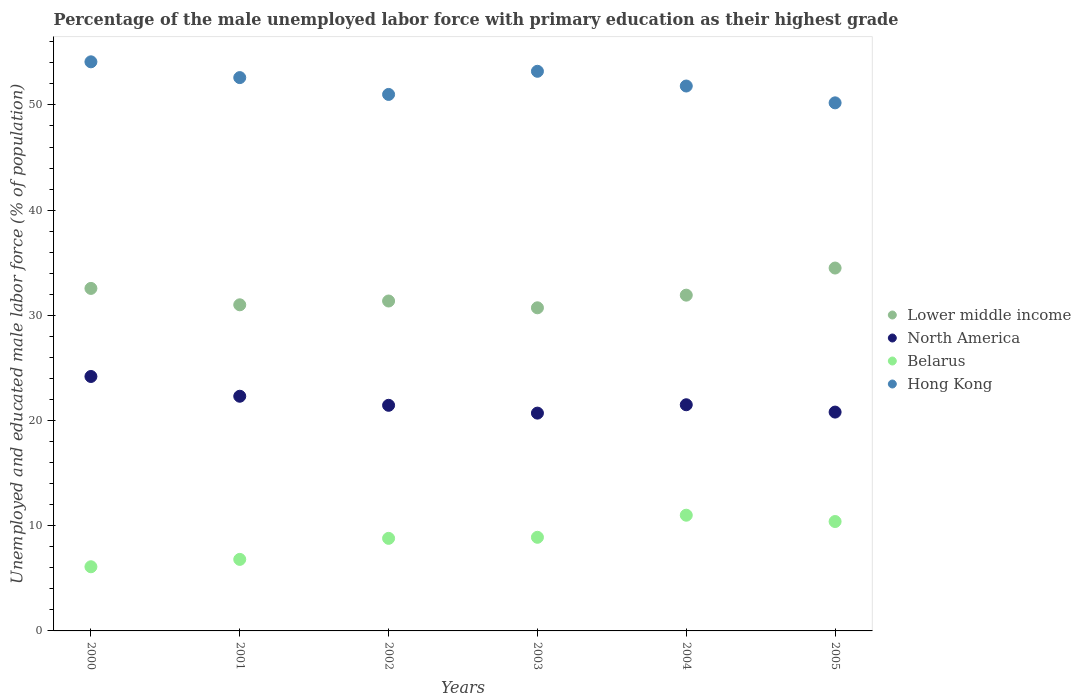How many different coloured dotlines are there?
Provide a succinct answer. 4. Is the number of dotlines equal to the number of legend labels?
Your answer should be compact. Yes. What is the percentage of the unemployed male labor force with primary education in Belarus in 2000?
Keep it short and to the point. 6.1. Across all years, what is the maximum percentage of the unemployed male labor force with primary education in Hong Kong?
Give a very brief answer. 54.1. Across all years, what is the minimum percentage of the unemployed male labor force with primary education in Hong Kong?
Ensure brevity in your answer.  50.2. What is the total percentage of the unemployed male labor force with primary education in North America in the graph?
Provide a succinct answer. 130.95. What is the difference between the percentage of the unemployed male labor force with primary education in Hong Kong in 2000 and that in 2004?
Make the answer very short. 2.3. What is the difference between the percentage of the unemployed male labor force with primary education in Hong Kong in 2004 and the percentage of the unemployed male labor force with primary education in Lower middle income in 2005?
Your answer should be compact. 17.3. What is the average percentage of the unemployed male labor force with primary education in Lower middle income per year?
Give a very brief answer. 32.01. In the year 2003, what is the difference between the percentage of the unemployed male labor force with primary education in Belarus and percentage of the unemployed male labor force with primary education in Hong Kong?
Make the answer very short. -44.3. In how many years, is the percentage of the unemployed male labor force with primary education in Lower middle income greater than 54 %?
Ensure brevity in your answer.  0. What is the ratio of the percentage of the unemployed male labor force with primary education in Lower middle income in 2003 to that in 2004?
Give a very brief answer. 0.96. Is the difference between the percentage of the unemployed male labor force with primary education in Belarus in 2002 and 2005 greater than the difference between the percentage of the unemployed male labor force with primary education in Hong Kong in 2002 and 2005?
Your answer should be compact. No. What is the difference between the highest and the second highest percentage of the unemployed male labor force with primary education in Lower middle income?
Make the answer very short. 1.94. What is the difference between the highest and the lowest percentage of the unemployed male labor force with primary education in North America?
Keep it short and to the point. 3.48. In how many years, is the percentage of the unemployed male labor force with primary education in North America greater than the average percentage of the unemployed male labor force with primary education in North America taken over all years?
Give a very brief answer. 2. Is the sum of the percentage of the unemployed male labor force with primary education in Hong Kong in 2000 and 2002 greater than the maximum percentage of the unemployed male labor force with primary education in Belarus across all years?
Ensure brevity in your answer.  Yes. Is it the case that in every year, the sum of the percentage of the unemployed male labor force with primary education in Lower middle income and percentage of the unemployed male labor force with primary education in Belarus  is greater than the sum of percentage of the unemployed male labor force with primary education in Hong Kong and percentage of the unemployed male labor force with primary education in North America?
Offer a terse response. No. Is it the case that in every year, the sum of the percentage of the unemployed male labor force with primary education in Lower middle income and percentage of the unemployed male labor force with primary education in Belarus  is greater than the percentage of the unemployed male labor force with primary education in North America?
Your answer should be compact. Yes. How many dotlines are there?
Give a very brief answer. 4. Are the values on the major ticks of Y-axis written in scientific E-notation?
Give a very brief answer. No. Does the graph contain any zero values?
Make the answer very short. No. What is the title of the graph?
Your response must be concise. Percentage of the male unemployed labor force with primary education as their highest grade. What is the label or title of the Y-axis?
Give a very brief answer. Unemployed and educated male labor force (% of population). What is the Unemployed and educated male labor force (% of population) in Lower middle income in 2000?
Provide a short and direct response. 32.56. What is the Unemployed and educated male labor force (% of population) in North America in 2000?
Make the answer very short. 24.19. What is the Unemployed and educated male labor force (% of population) in Belarus in 2000?
Your answer should be very brief. 6.1. What is the Unemployed and educated male labor force (% of population) of Hong Kong in 2000?
Offer a terse response. 54.1. What is the Unemployed and educated male labor force (% of population) of Lower middle income in 2001?
Keep it short and to the point. 31. What is the Unemployed and educated male labor force (% of population) in North America in 2001?
Ensure brevity in your answer.  22.31. What is the Unemployed and educated male labor force (% of population) of Belarus in 2001?
Offer a very short reply. 6.8. What is the Unemployed and educated male labor force (% of population) in Hong Kong in 2001?
Ensure brevity in your answer.  52.6. What is the Unemployed and educated male labor force (% of population) of Lower middle income in 2002?
Give a very brief answer. 31.36. What is the Unemployed and educated male labor force (% of population) in North America in 2002?
Your answer should be compact. 21.45. What is the Unemployed and educated male labor force (% of population) of Belarus in 2002?
Your answer should be compact. 8.8. What is the Unemployed and educated male labor force (% of population) in Lower middle income in 2003?
Make the answer very short. 30.72. What is the Unemployed and educated male labor force (% of population) of North America in 2003?
Offer a terse response. 20.7. What is the Unemployed and educated male labor force (% of population) in Belarus in 2003?
Your response must be concise. 8.9. What is the Unemployed and educated male labor force (% of population) of Hong Kong in 2003?
Give a very brief answer. 53.2. What is the Unemployed and educated male labor force (% of population) of Lower middle income in 2004?
Provide a short and direct response. 31.92. What is the Unemployed and educated male labor force (% of population) in North America in 2004?
Offer a very short reply. 21.5. What is the Unemployed and educated male labor force (% of population) in Hong Kong in 2004?
Your answer should be compact. 51.8. What is the Unemployed and educated male labor force (% of population) of Lower middle income in 2005?
Offer a terse response. 34.5. What is the Unemployed and educated male labor force (% of population) in North America in 2005?
Give a very brief answer. 20.8. What is the Unemployed and educated male labor force (% of population) of Belarus in 2005?
Your response must be concise. 10.4. What is the Unemployed and educated male labor force (% of population) of Hong Kong in 2005?
Your response must be concise. 50.2. Across all years, what is the maximum Unemployed and educated male labor force (% of population) of Lower middle income?
Make the answer very short. 34.5. Across all years, what is the maximum Unemployed and educated male labor force (% of population) of North America?
Provide a succinct answer. 24.19. Across all years, what is the maximum Unemployed and educated male labor force (% of population) in Hong Kong?
Your answer should be compact. 54.1. Across all years, what is the minimum Unemployed and educated male labor force (% of population) of Lower middle income?
Your response must be concise. 30.72. Across all years, what is the minimum Unemployed and educated male labor force (% of population) in North America?
Offer a terse response. 20.7. Across all years, what is the minimum Unemployed and educated male labor force (% of population) in Belarus?
Give a very brief answer. 6.1. Across all years, what is the minimum Unemployed and educated male labor force (% of population) of Hong Kong?
Give a very brief answer. 50.2. What is the total Unemployed and educated male labor force (% of population) of Lower middle income in the graph?
Your response must be concise. 192.05. What is the total Unemployed and educated male labor force (% of population) of North America in the graph?
Your answer should be very brief. 130.95. What is the total Unemployed and educated male labor force (% of population) of Belarus in the graph?
Your response must be concise. 52. What is the total Unemployed and educated male labor force (% of population) of Hong Kong in the graph?
Your answer should be very brief. 312.9. What is the difference between the Unemployed and educated male labor force (% of population) of Lower middle income in 2000 and that in 2001?
Your answer should be very brief. 1.56. What is the difference between the Unemployed and educated male labor force (% of population) of North America in 2000 and that in 2001?
Provide a succinct answer. 1.88. What is the difference between the Unemployed and educated male labor force (% of population) in Lower middle income in 2000 and that in 2002?
Provide a short and direct response. 1.2. What is the difference between the Unemployed and educated male labor force (% of population) in North America in 2000 and that in 2002?
Give a very brief answer. 2.74. What is the difference between the Unemployed and educated male labor force (% of population) in Belarus in 2000 and that in 2002?
Provide a succinct answer. -2.7. What is the difference between the Unemployed and educated male labor force (% of population) in Lower middle income in 2000 and that in 2003?
Your response must be concise. 1.84. What is the difference between the Unemployed and educated male labor force (% of population) of North America in 2000 and that in 2003?
Ensure brevity in your answer.  3.48. What is the difference between the Unemployed and educated male labor force (% of population) of Lower middle income in 2000 and that in 2004?
Offer a terse response. 0.64. What is the difference between the Unemployed and educated male labor force (% of population) in North America in 2000 and that in 2004?
Offer a terse response. 2.69. What is the difference between the Unemployed and educated male labor force (% of population) in Lower middle income in 2000 and that in 2005?
Your response must be concise. -1.94. What is the difference between the Unemployed and educated male labor force (% of population) in North America in 2000 and that in 2005?
Ensure brevity in your answer.  3.38. What is the difference between the Unemployed and educated male labor force (% of population) of Belarus in 2000 and that in 2005?
Offer a terse response. -4.3. What is the difference between the Unemployed and educated male labor force (% of population) in Hong Kong in 2000 and that in 2005?
Give a very brief answer. 3.9. What is the difference between the Unemployed and educated male labor force (% of population) of Lower middle income in 2001 and that in 2002?
Your answer should be compact. -0.36. What is the difference between the Unemployed and educated male labor force (% of population) of North America in 2001 and that in 2002?
Offer a very short reply. 0.86. What is the difference between the Unemployed and educated male labor force (% of population) in Lower middle income in 2001 and that in 2003?
Your response must be concise. 0.28. What is the difference between the Unemployed and educated male labor force (% of population) in North America in 2001 and that in 2003?
Your answer should be very brief. 1.6. What is the difference between the Unemployed and educated male labor force (% of population) of Hong Kong in 2001 and that in 2003?
Offer a terse response. -0.6. What is the difference between the Unemployed and educated male labor force (% of population) of Lower middle income in 2001 and that in 2004?
Make the answer very short. -0.92. What is the difference between the Unemployed and educated male labor force (% of population) in North America in 2001 and that in 2004?
Ensure brevity in your answer.  0.81. What is the difference between the Unemployed and educated male labor force (% of population) in Belarus in 2001 and that in 2004?
Keep it short and to the point. -4.2. What is the difference between the Unemployed and educated male labor force (% of population) of Lower middle income in 2001 and that in 2005?
Your response must be concise. -3.49. What is the difference between the Unemployed and educated male labor force (% of population) of North America in 2001 and that in 2005?
Your answer should be very brief. 1.51. What is the difference between the Unemployed and educated male labor force (% of population) of Lower middle income in 2002 and that in 2003?
Offer a very short reply. 0.65. What is the difference between the Unemployed and educated male labor force (% of population) in North America in 2002 and that in 2003?
Offer a very short reply. 0.74. What is the difference between the Unemployed and educated male labor force (% of population) in Lower middle income in 2002 and that in 2004?
Make the answer very short. -0.56. What is the difference between the Unemployed and educated male labor force (% of population) in North America in 2002 and that in 2004?
Offer a terse response. -0.05. What is the difference between the Unemployed and educated male labor force (% of population) of Belarus in 2002 and that in 2004?
Keep it short and to the point. -2.2. What is the difference between the Unemployed and educated male labor force (% of population) of Lower middle income in 2002 and that in 2005?
Offer a very short reply. -3.13. What is the difference between the Unemployed and educated male labor force (% of population) of North America in 2002 and that in 2005?
Offer a terse response. 0.65. What is the difference between the Unemployed and educated male labor force (% of population) in Belarus in 2002 and that in 2005?
Provide a short and direct response. -1.6. What is the difference between the Unemployed and educated male labor force (% of population) in Lower middle income in 2003 and that in 2004?
Your answer should be compact. -1.2. What is the difference between the Unemployed and educated male labor force (% of population) of North America in 2003 and that in 2004?
Ensure brevity in your answer.  -0.8. What is the difference between the Unemployed and educated male labor force (% of population) of Hong Kong in 2003 and that in 2004?
Keep it short and to the point. 1.4. What is the difference between the Unemployed and educated male labor force (% of population) in Lower middle income in 2003 and that in 2005?
Make the answer very short. -3.78. What is the difference between the Unemployed and educated male labor force (% of population) of North America in 2003 and that in 2005?
Keep it short and to the point. -0.1. What is the difference between the Unemployed and educated male labor force (% of population) of Belarus in 2003 and that in 2005?
Offer a very short reply. -1.5. What is the difference between the Unemployed and educated male labor force (% of population) in Lower middle income in 2004 and that in 2005?
Keep it short and to the point. -2.58. What is the difference between the Unemployed and educated male labor force (% of population) in North America in 2004 and that in 2005?
Keep it short and to the point. 0.7. What is the difference between the Unemployed and educated male labor force (% of population) of Belarus in 2004 and that in 2005?
Offer a terse response. 0.6. What is the difference between the Unemployed and educated male labor force (% of population) of Hong Kong in 2004 and that in 2005?
Offer a very short reply. 1.6. What is the difference between the Unemployed and educated male labor force (% of population) in Lower middle income in 2000 and the Unemployed and educated male labor force (% of population) in North America in 2001?
Give a very brief answer. 10.25. What is the difference between the Unemployed and educated male labor force (% of population) in Lower middle income in 2000 and the Unemployed and educated male labor force (% of population) in Belarus in 2001?
Your answer should be compact. 25.76. What is the difference between the Unemployed and educated male labor force (% of population) in Lower middle income in 2000 and the Unemployed and educated male labor force (% of population) in Hong Kong in 2001?
Offer a very short reply. -20.04. What is the difference between the Unemployed and educated male labor force (% of population) of North America in 2000 and the Unemployed and educated male labor force (% of population) of Belarus in 2001?
Your answer should be very brief. 17.39. What is the difference between the Unemployed and educated male labor force (% of population) in North America in 2000 and the Unemployed and educated male labor force (% of population) in Hong Kong in 2001?
Give a very brief answer. -28.41. What is the difference between the Unemployed and educated male labor force (% of population) of Belarus in 2000 and the Unemployed and educated male labor force (% of population) of Hong Kong in 2001?
Provide a short and direct response. -46.5. What is the difference between the Unemployed and educated male labor force (% of population) of Lower middle income in 2000 and the Unemployed and educated male labor force (% of population) of North America in 2002?
Offer a very short reply. 11.11. What is the difference between the Unemployed and educated male labor force (% of population) in Lower middle income in 2000 and the Unemployed and educated male labor force (% of population) in Belarus in 2002?
Make the answer very short. 23.76. What is the difference between the Unemployed and educated male labor force (% of population) of Lower middle income in 2000 and the Unemployed and educated male labor force (% of population) of Hong Kong in 2002?
Keep it short and to the point. -18.44. What is the difference between the Unemployed and educated male labor force (% of population) in North America in 2000 and the Unemployed and educated male labor force (% of population) in Belarus in 2002?
Give a very brief answer. 15.39. What is the difference between the Unemployed and educated male labor force (% of population) in North America in 2000 and the Unemployed and educated male labor force (% of population) in Hong Kong in 2002?
Provide a succinct answer. -26.81. What is the difference between the Unemployed and educated male labor force (% of population) of Belarus in 2000 and the Unemployed and educated male labor force (% of population) of Hong Kong in 2002?
Ensure brevity in your answer.  -44.9. What is the difference between the Unemployed and educated male labor force (% of population) in Lower middle income in 2000 and the Unemployed and educated male labor force (% of population) in North America in 2003?
Make the answer very short. 11.86. What is the difference between the Unemployed and educated male labor force (% of population) of Lower middle income in 2000 and the Unemployed and educated male labor force (% of population) of Belarus in 2003?
Provide a succinct answer. 23.66. What is the difference between the Unemployed and educated male labor force (% of population) in Lower middle income in 2000 and the Unemployed and educated male labor force (% of population) in Hong Kong in 2003?
Give a very brief answer. -20.64. What is the difference between the Unemployed and educated male labor force (% of population) in North America in 2000 and the Unemployed and educated male labor force (% of population) in Belarus in 2003?
Provide a succinct answer. 15.29. What is the difference between the Unemployed and educated male labor force (% of population) of North America in 2000 and the Unemployed and educated male labor force (% of population) of Hong Kong in 2003?
Your answer should be very brief. -29.01. What is the difference between the Unemployed and educated male labor force (% of population) of Belarus in 2000 and the Unemployed and educated male labor force (% of population) of Hong Kong in 2003?
Give a very brief answer. -47.1. What is the difference between the Unemployed and educated male labor force (% of population) of Lower middle income in 2000 and the Unemployed and educated male labor force (% of population) of North America in 2004?
Keep it short and to the point. 11.06. What is the difference between the Unemployed and educated male labor force (% of population) in Lower middle income in 2000 and the Unemployed and educated male labor force (% of population) in Belarus in 2004?
Make the answer very short. 21.56. What is the difference between the Unemployed and educated male labor force (% of population) of Lower middle income in 2000 and the Unemployed and educated male labor force (% of population) of Hong Kong in 2004?
Your answer should be compact. -19.24. What is the difference between the Unemployed and educated male labor force (% of population) in North America in 2000 and the Unemployed and educated male labor force (% of population) in Belarus in 2004?
Provide a short and direct response. 13.19. What is the difference between the Unemployed and educated male labor force (% of population) in North America in 2000 and the Unemployed and educated male labor force (% of population) in Hong Kong in 2004?
Your answer should be compact. -27.61. What is the difference between the Unemployed and educated male labor force (% of population) of Belarus in 2000 and the Unemployed and educated male labor force (% of population) of Hong Kong in 2004?
Your answer should be compact. -45.7. What is the difference between the Unemployed and educated male labor force (% of population) of Lower middle income in 2000 and the Unemployed and educated male labor force (% of population) of North America in 2005?
Your response must be concise. 11.76. What is the difference between the Unemployed and educated male labor force (% of population) in Lower middle income in 2000 and the Unemployed and educated male labor force (% of population) in Belarus in 2005?
Provide a short and direct response. 22.16. What is the difference between the Unemployed and educated male labor force (% of population) of Lower middle income in 2000 and the Unemployed and educated male labor force (% of population) of Hong Kong in 2005?
Provide a succinct answer. -17.64. What is the difference between the Unemployed and educated male labor force (% of population) of North America in 2000 and the Unemployed and educated male labor force (% of population) of Belarus in 2005?
Your answer should be compact. 13.79. What is the difference between the Unemployed and educated male labor force (% of population) of North America in 2000 and the Unemployed and educated male labor force (% of population) of Hong Kong in 2005?
Give a very brief answer. -26.01. What is the difference between the Unemployed and educated male labor force (% of population) of Belarus in 2000 and the Unemployed and educated male labor force (% of population) of Hong Kong in 2005?
Your answer should be very brief. -44.1. What is the difference between the Unemployed and educated male labor force (% of population) of Lower middle income in 2001 and the Unemployed and educated male labor force (% of population) of North America in 2002?
Make the answer very short. 9.55. What is the difference between the Unemployed and educated male labor force (% of population) of Lower middle income in 2001 and the Unemployed and educated male labor force (% of population) of Belarus in 2002?
Your answer should be compact. 22.2. What is the difference between the Unemployed and educated male labor force (% of population) in Lower middle income in 2001 and the Unemployed and educated male labor force (% of population) in Hong Kong in 2002?
Provide a short and direct response. -20. What is the difference between the Unemployed and educated male labor force (% of population) in North America in 2001 and the Unemployed and educated male labor force (% of population) in Belarus in 2002?
Offer a very short reply. 13.51. What is the difference between the Unemployed and educated male labor force (% of population) of North America in 2001 and the Unemployed and educated male labor force (% of population) of Hong Kong in 2002?
Offer a terse response. -28.69. What is the difference between the Unemployed and educated male labor force (% of population) in Belarus in 2001 and the Unemployed and educated male labor force (% of population) in Hong Kong in 2002?
Your response must be concise. -44.2. What is the difference between the Unemployed and educated male labor force (% of population) in Lower middle income in 2001 and the Unemployed and educated male labor force (% of population) in North America in 2003?
Offer a very short reply. 10.3. What is the difference between the Unemployed and educated male labor force (% of population) of Lower middle income in 2001 and the Unemployed and educated male labor force (% of population) of Belarus in 2003?
Your response must be concise. 22.1. What is the difference between the Unemployed and educated male labor force (% of population) of Lower middle income in 2001 and the Unemployed and educated male labor force (% of population) of Hong Kong in 2003?
Offer a very short reply. -22.2. What is the difference between the Unemployed and educated male labor force (% of population) of North America in 2001 and the Unemployed and educated male labor force (% of population) of Belarus in 2003?
Offer a terse response. 13.41. What is the difference between the Unemployed and educated male labor force (% of population) in North America in 2001 and the Unemployed and educated male labor force (% of population) in Hong Kong in 2003?
Offer a terse response. -30.89. What is the difference between the Unemployed and educated male labor force (% of population) of Belarus in 2001 and the Unemployed and educated male labor force (% of population) of Hong Kong in 2003?
Keep it short and to the point. -46.4. What is the difference between the Unemployed and educated male labor force (% of population) in Lower middle income in 2001 and the Unemployed and educated male labor force (% of population) in North America in 2004?
Your answer should be very brief. 9.5. What is the difference between the Unemployed and educated male labor force (% of population) in Lower middle income in 2001 and the Unemployed and educated male labor force (% of population) in Belarus in 2004?
Your response must be concise. 20. What is the difference between the Unemployed and educated male labor force (% of population) in Lower middle income in 2001 and the Unemployed and educated male labor force (% of population) in Hong Kong in 2004?
Offer a terse response. -20.8. What is the difference between the Unemployed and educated male labor force (% of population) of North America in 2001 and the Unemployed and educated male labor force (% of population) of Belarus in 2004?
Offer a very short reply. 11.31. What is the difference between the Unemployed and educated male labor force (% of population) in North America in 2001 and the Unemployed and educated male labor force (% of population) in Hong Kong in 2004?
Your answer should be compact. -29.49. What is the difference between the Unemployed and educated male labor force (% of population) of Belarus in 2001 and the Unemployed and educated male labor force (% of population) of Hong Kong in 2004?
Offer a very short reply. -45. What is the difference between the Unemployed and educated male labor force (% of population) in Lower middle income in 2001 and the Unemployed and educated male labor force (% of population) in North America in 2005?
Offer a terse response. 10.2. What is the difference between the Unemployed and educated male labor force (% of population) of Lower middle income in 2001 and the Unemployed and educated male labor force (% of population) of Belarus in 2005?
Make the answer very short. 20.6. What is the difference between the Unemployed and educated male labor force (% of population) in Lower middle income in 2001 and the Unemployed and educated male labor force (% of population) in Hong Kong in 2005?
Your answer should be very brief. -19.2. What is the difference between the Unemployed and educated male labor force (% of population) of North America in 2001 and the Unemployed and educated male labor force (% of population) of Belarus in 2005?
Offer a very short reply. 11.91. What is the difference between the Unemployed and educated male labor force (% of population) of North America in 2001 and the Unemployed and educated male labor force (% of population) of Hong Kong in 2005?
Provide a short and direct response. -27.89. What is the difference between the Unemployed and educated male labor force (% of population) of Belarus in 2001 and the Unemployed and educated male labor force (% of population) of Hong Kong in 2005?
Your answer should be very brief. -43.4. What is the difference between the Unemployed and educated male labor force (% of population) in Lower middle income in 2002 and the Unemployed and educated male labor force (% of population) in North America in 2003?
Offer a terse response. 10.66. What is the difference between the Unemployed and educated male labor force (% of population) of Lower middle income in 2002 and the Unemployed and educated male labor force (% of population) of Belarus in 2003?
Your answer should be very brief. 22.46. What is the difference between the Unemployed and educated male labor force (% of population) in Lower middle income in 2002 and the Unemployed and educated male labor force (% of population) in Hong Kong in 2003?
Provide a succinct answer. -21.84. What is the difference between the Unemployed and educated male labor force (% of population) of North America in 2002 and the Unemployed and educated male labor force (% of population) of Belarus in 2003?
Offer a terse response. 12.55. What is the difference between the Unemployed and educated male labor force (% of population) in North America in 2002 and the Unemployed and educated male labor force (% of population) in Hong Kong in 2003?
Your response must be concise. -31.75. What is the difference between the Unemployed and educated male labor force (% of population) in Belarus in 2002 and the Unemployed and educated male labor force (% of population) in Hong Kong in 2003?
Offer a terse response. -44.4. What is the difference between the Unemployed and educated male labor force (% of population) in Lower middle income in 2002 and the Unemployed and educated male labor force (% of population) in North America in 2004?
Your response must be concise. 9.86. What is the difference between the Unemployed and educated male labor force (% of population) of Lower middle income in 2002 and the Unemployed and educated male labor force (% of population) of Belarus in 2004?
Offer a terse response. 20.36. What is the difference between the Unemployed and educated male labor force (% of population) of Lower middle income in 2002 and the Unemployed and educated male labor force (% of population) of Hong Kong in 2004?
Make the answer very short. -20.44. What is the difference between the Unemployed and educated male labor force (% of population) in North America in 2002 and the Unemployed and educated male labor force (% of population) in Belarus in 2004?
Provide a short and direct response. 10.45. What is the difference between the Unemployed and educated male labor force (% of population) in North America in 2002 and the Unemployed and educated male labor force (% of population) in Hong Kong in 2004?
Make the answer very short. -30.35. What is the difference between the Unemployed and educated male labor force (% of population) of Belarus in 2002 and the Unemployed and educated male labor force (% of population) of Hong Kong in 2004?
Offer a very short reply. -43. What is the difference between the Unemployed and educated male labor force (% of population) in Lower middle income in 2002 and the Unemployed and educated male labor force (% of population) in North America in 2005?
Provide a succinct answer. 10.56. What is the difference between the Unemployed and educated male labor force (% of population) in Lower middle income in 2002 and the Unemployed and educated male labor force (% of population) in Belarus in 2005?
Provide a succinct answer. 20.96. What is the difference between the Unemployed and educated male labor force (% of population) of Lower middle income in 2002 and the Unemployed and educated male labor force (% of population) of Hong Kong in 2005?
Give a very brief answer. -18.84. What is the difference between the Unemployed and educated male labor force (% of population) in North America in 2002 and the Unemployed and educated male labor force (% of population) in Belarus in 2005?
Provide a short and direct response. 11.05. What is the difference between the Unemployed and educated male labor force (% of population) in North America in 2002 and the Unemployed and educated male labor force (% of population) in Hong Kong in 2005?
Make the answer very short. -28.75. What is the difference between the Unemployed and educated male labor force (% of population) of Belarus in 2002 and the Unemployed and educated male labor force (% of population) of Hong Kong in 2005?
Ensure brevity in your answer.  -41.4. What is the difference between the Unemployed and educated male labor force (% of population) of Lower middle income in 2003 and the Unemployed and educated male labor force (% of population) of North America in 2004?
Your answer should be very brief. 9.22. What is the difference between the Unemployed and educated male labor force (% of population) of Lower middle income in 2003 and the Unemployed and educated male labor force (% of population) of Belarus in 2004?
Provide a succinct answer. 19.72. What is the difference between the Unemployed and educated male labor force (% of population) in Lower middle income in 2003 and the Unemployed and educated male labor force (% of population) in Hong Kong in 2004?
Your answer should be compact. -21.08. What is the difference between the Unemployed and educated male labor force (% of population) in North America in 2003 and the Unemployed and educated male labor force (% of population) in Belarus in 2004?
Offer a terse response. 9.7. What is the difference between the Unemployed and educated male labor force (% of population) of North America in 2003 and the Unemployed and educated male labor force (% of population) of Hong Kong in 2004?
Provide a succinct answer. -31.1. What is the difference between the Unemployed and educated male labor force (% of population) in Belarus in 2003 and the Unemployed and educated male labor force (% of population) in Hong Kong in 2004?
Your answer should be compact. -42.9. What is the difference between the Unemployed and educated male labor force (% of population) in Lower middle income in 2003 and the Unemployed and educated male labor force (% of population) in North America in 2005?
Keep it short and to the point. 9.91. What is the difference between the Unemployed and educated male labor force (% of population) of Lower middle income in 2003 and the Unemployed and educated male labor force (% of population) of Belarus in 2005?
Your answer should be compact. 20.32. What is the difference between the Unemployed and educated male labor force (% of population) of Lower middle income in 2003 and the Unemployed and educated male labor force (% of population) of Hong Kong in 2005?
Give a very brief answer. -19.48. What is the difference between the Unemployed and educated male labor force (% of population) in North America in 2003 and the Unemployed and educated male labor force (% of population) in Belarus in 2005?
Offer a terse response. 10.3. What is the difference between the Unemployed and educated male labor force (% of population) of North America in 2003 and the Unemployed and educated male labor force (% of population) of Hong Kong in 2005?
Your answer should be compact. -29.5. What is the difference between the Unemployed and educated male labor force (% of population) of Belarus in 2003 and the Unemployed and educated male labor force (% of population) of Hong Kong in 2005?
Give a very brief answer. -41.3. What is the difference between the Unemployed and educated male labor force (% of population) in Lower middle income in 2004 and the Unemployed and educated male labor force (% of population) in North America in 2005?
Your answer should be compact. 11.12. What is the difference between the Unemployed and educated male labor force (% of population) in Lower middle income in 2004 and the Unemployed and educated male labor force (% of population) in Belarus in 2005?
Offer a terse response. 21.52. What is the difference between the Unemployed and educated male labor force (% of population) in Lower middle income in 2004 and the Unemployed and educated male labor force (% of population) in Hong Kong in 2005?
Provide a succinct answer. -18.28. What is the difference between the Unemployed and educated male labor force (% of population) of North America in 2004 and the Unemployed and educated male labor force (% of population) of Belarus in 2005?
Give a very brief answer. 11.1. What is the difference between the Unemployed and educated male labor force (% of population) in North America in 2004 and the Unemployed and educated male labor force (% of population) in Hong Kong in 2005?
Offer a terse response. -28.7. What is the difference between the Unemployed and educated male labor force (% of population) in Belarus in 2004 and the Unemployed and educated male labor force (% of population) in Hong Kong in 2005?
Offer a very short reply. -39.2. What is the average Unemployed and educated male labor force (% of population) of Lower middle income per year?
Keep it short and to the point. 32.01. What is the average Unemployed and educated male labor force (% of population) of North America per year?
Keep it short and to the point. 21.83. What is the average Unemployed and educated male labor force (% of population) in Belarus per year?
Provide a short and direct response. 8.67. What is the average Unemployed and educated male labor force (% of population) in Hong Kong per year?
Your answer should be very brief. 52.15. In the year 2000, what is the difference between the Unemployed and educated male labor force (% of population) of Lower middle income and Unemployed and educated male labor force (% of population) of North America?
Give a very brief answer. 8.37. In the year 2000, what is the difference between the Unemployed and educated male labor force (% of population) in Lower middle income and Unemployed and educated male labor force (% of population) in Belarus?
Offer a terse response. 26.46. In the year 2000, what is the difference between the Unemployed and educated male labor force (% of population) in Lower middle income and Unemployed and educated male labor force (% of population) in Hong Kong?
Provide a succinct answer. -21.54. In the year 2000, what is the difference between the Unemployed and educated male labor force (% of population) of North America and Unemployed and educated male labor force (% of population) of Belarus?
Offer a terse response. 18.09. In the year 2000, what is the difference between the Unemployed and educated male labor force (% of population) of North America and Unemployed and educated male labor force (% of population) of Hong Kong?
Provide a succinct answer. -29.91. In the year 2000, what is the difference between the Unemployed and educated male labor force (% of population) of Belarus and Unemployed and educated male labor force (% of population) of Hong Kong?
Ensure brevity in your answer.  -48. In the year 2001, what is the difference between the Unemployed and educated male labor force (% of population) of Lower middle income and Unemployed and educated male labor force (% of population) of North America?
Give a very brief answer. 8.69. In the year 2001, what is the difference between the Unemployed and educated male labor force (% of population) in Lower middle income and Unemployed and educated male labor force (% of population) in Belarus?
Offer a very short reply. 24.2. In the year 2001, what is the difference between the Unemployed and educated male labor force (% of population) of Lower middle income and Unemployed and educated male labor force (% of population) of Hong Kong?
Make the answer very short. -21.6. In the year 2001, what is the difference between the Unemployed and educated male labor force (% of population) in North America and Unemployed and educated male labor force (% of population) in Belarus?
Make the answer very short. 15.51. In the year 2001, what is the difference between the Unemployed and educated male labor force (% of population) of North America and Unemployed and educated male labor force (% of population) of Hong Kong?
Your answer should be compact. -30.29. In the year 2001, what is the difference between the Unemployed and educated male labor force (% of population) of Belarus and Unemployed and educated male labor force (% of population) of Hong Kong?
Ensure brevity in your answer.  -45.8. In the year 2002, what is the difference between the Unemployed and educated male labor force (% of population) in Lower middle income and Unemployed and educated male labor force (% of population) in North America?
Give a very brief answer. 9.91. In the year 2002, what is the difference between the Unemployed and educated male labor force (% of population) in Lower middle income and Unemployed and educated male labor force (% of population) in Belarus?
Ensure brevity in your answer.  22.56. In the year 2002, what is the difference between the Unemployed and educated male labor force (% of population) in Lower middle income and Unemployed and educated male labor force (% of population) in Hong Kong?
Offer a terse response. -19.64. In the year 2002, what is the difference between the Unemployed and educated male labor force (% of population) in North America and Unemployed and educated male labor force (% of population) in Belarus?
Provide a short and direct response. 12.65. In the year 2002, what is the difference between the Unemployed and educated male labor force (% of population) in North America and Unemployed and educated male labor force (% of population) in Hong Kong?
Provide a short and direct response. -29.55. In the year 2002, what is the difference between the Unemployed and educated male labor force (% of population) of Belarus and Unemployed and educated male labor force (% of population) of Hong Kong?
Offer a very short reply. -42.2. In the year 2003, what is the difference between the Unemployed and educated male labor force (% of population) of Lower middle income and Unemployed and educated male labor force (% of population) of North America?
Offer a terse response. 10.01. In the year 2003, what is the difference between the Unemployed and educated male labor force (% of population) in Lower middle income and Unemployed and educated male labor force (% of population) in Belarus?
Make the answer very short. 21.82. In the year 2003, what is the difference between the Unemployed and educated male labor force (% of population) in Lower middle income and Unemployed and educated male labor force (% of population) in Hong Kong?
Provide a succinct answer. -22.48. In the year 2003, what is the difference between the Unemployed and educated male labor force (% of population) in North America and Unemployed and educated male labor force (% of population) in Belarus?
Provide a succinct answer. 11.8. In the year 2003, what is the difference between the Unemployed and educated male labor force (% of population) of North America and Unemployed and educated male labor force (% of population) of Hong Kong?
Offer a very short reply. -32.5. In the year 2003, what is the difference between the Unemployed and educated male labor force (% of population) of Belarus and Unemployed and educated male labor force (% of population) of Hong Kong?
Ensure brevity in your answer.  -44.3. In the year 2004, what is the difference between the Unemployed and educated male labor force (% of population) of Lower middle income and Unemployed and educated male labor force (% of population) of North America?
Offer a very short reply. 10.42. In the year 2004, what is the difference between the Unemployed and educated male labor force (% of population) in Lower middle income and Unemployed and educated male labor force (% of population) in Belarus?
Your answer should be compact. 20.92. In the year 2004, what is the difference between the Unemployed and educated male labor force (% of population) of Lower middle income and Unemployed and educated male labor force (% of population) of Hong Kong?
Give a very brief answer. -19.88. In the year 2004, what is the difference between the Unemployed and educated male labor force (% of population) of North America and Unemployed and educated male labor force (% of population) of Belarus?
Make the answer very short. 10.5. In the year 2004, what is the difference between the Unemployed and educated male labor force (% of population) in North America and Unemployed and educated male labor force (% of population) in Hong Kong?
Your answer should be very brief. -30.3. In the year 2004, what is the difference between the Unemployed and educated male labor force (% of population) in Belarus and Unemployed and educated male labor force (% of population) in Hong Kong?
Give a very brief answer. -40.8. In the year 2005, what is the difference between the Unemployed and educated male labor force (% of population) in Lower middle income and Unemployed and educated male labor force (% of population) in North America?
Provide a succinct answer. 13.69. In the year 2005, what is the difference between the Unemployed and educated male labor force (% of population) in Lower middle income and Unemployed and educated male labor force (% of population) in Belarus?
Make the answer very short. 24.1. In the year 2005, what is the difference between the Unemployed and educated male labor force (% of population) in Lower middle income and Unemployed and educated male labor force (% of population) in Hong Kong?
Keep it short and to the point. -15.7. In the year 2005, what is the difference between the Unemployed and educated male labor force (% of population) in North America and Unemployed and educated male labor force (% of population) in Belarus?
Offer a very short reply. 10.4. In the year 2005, what is the difference between the Unemployed and educated male labor force (% of population) in North America and Unemployed and educated male labor force (% of population) in Hong Kong?
Your response must be concise. -29.4. In the year 2005, what is the difference between the Unemployed and educated male labor force (% of population) of Belarus and Unemployed and educated male labor force (% of population) of Hong Kong?
Give a very brief answer. -39.8. What is the ratio of the Unemployed and educated male labor force (% of population) in Lower middle income in 2000 to that in 2001?
Your answer should be very brief. 1.05. What is the ratio of the Unemployed and educated male labor force (% of population) in North America in 2000 to that in 2001?
Your answer should be very brief. 1.08. What is the ratio of the Unemployed and educated male labor force (% of population) in Belarus in 2000 to that in 2001?
Your answer should be very brief. 0.9. What is the ratio of the Unemployed and educated male labor force (% of population) of Hong Kong in 2000 to that in 2001?
Make the answer very short. 1.03. What is the ratio of the Unemployed and educated male labor force (% of population) of Lower middle income in 2000 to that in 2002?
Provide a succinct answer. 1.04. What is the ratio of the Unemployed and educated male labor force (% of population) of North America in 2000 to that in 2002?
Your response must be concise. 1.13. What is the ratio of the Unemployed and educated male labor force (% of population) in Belarus in 2000 to that in 2002?
Your answer should be compact. 0.69. What is the ratio of the Unemployed and educated male labor force (% of population) in Hong Kong in 2000 to that in 2002?
Provide a succinct answer. 1.06. What is the ratio of the Unemployed and educated male labor force (% of population) of Lower middle income in 2000 to that in 2003?
Give a very brief answer. 1.06. What is the ratio of the Unemployed and educated male labor force (% of population) of North America in 2000 to that in 2003?
Your response must be concise. 1.17. What is the ratio of the Unemployed and educated male labor force (% of population) of Belarus in 2000 to that in 2003?
Keep it short and to the point. 0.69. What is the ratio of the Unemployed and educated male labor force (% of population) in Hong Kong in 2000 to that in 2003?
Keep it short and to the point. 1.02. What is the ratio of the Unemployed and educated male labor force (% of population) of Lower middle income in 2000 to that in 2004?
Ensure brevity in your answer.  1.02. What is the ratio of the Unemployed and educated male labor force (% of population) of North America in 2000 to that in 2004?
Make the answer very short. 1.12. What is the ratio of the Unemployed and educated male labor force (% of population) of Belarus in 2000 to that in 2004?
Offer a very short reply. 0.55. What is the ratio of the Unemployed and educated male labor force (% of population) of Hong Kong in 2000 to that in 2004?
Provide a succinct answer. 1.04. What is the ratio of the Unemployed and educated male labor force (% of population) of Lower middle income in 2000 to that in 2005?
Ensure brevity in your answer.  0.94. What is the ratio of the Unemployed and educated male labor force (% of population) in North America in 2000 to that in 2005?
Your answer should be very brief. 1.16. What is the ratio of the Unemployed and educated male labor force (% of population) in Belarus in 2000 to that in 2005?
Make the answer very short. 0.59. What is the ratio of the Unemployed and educated male labor force (% of population) of Hong Kong in 2000 to that in 2005?
Give a very brief answer. 1.08. What is the ratio of the Unemployed and educated male labor force (% of population) in Lower middle income in 2001 to that in 2002?
Your response must be concise. 0.99. What is the ratio of the Unemployed and educated male labor force (% of population) in North America in 2001 to that in 2002?
Keep it short and to the point. 1.04. What is the ratio of the Unemployed and educated male labor force (% of population) in Belarus in 2001 to that in 2002?
Make the answer very short. 0.77. What is the ratio of the Unemployed and educated male labor force (% of population) in Hong Kong in 2001 to that in 2002?
Give a very brief answer. 1.03. What is the ratio of the Unemployed and educated male labor force (% of population) of Lower middle income in 2001 to that in 2003?
Keep it short and to the point. 1.01. What is the ratio of the Unemployed and educated male labor force (% of population) of North America in 2001 to that in 2003?
Make the answer very short. 1.08. What is the ratio of the Unemployed and educated male labor force (% of population) of Belarus in 2001 to that in 2003?
Keep it short and to the point. 0.76. What is the ratio of the Unemployed and educated male labor force (% of population) of Hong Kong in 2001 to that in 2003?
Offer a terse response. 0.99. What is the ratio of the Unemployed and educated male labor force (% of population) in Lower middle income in 2001 to that in 2004?
Your response must be concise. 0.97. What is the ratio of the Unemployed and educated male labor force (% of population) of North America in 2001 to that in 2004?
Your answer should be compact. 1.04. What is the ratio of the Unemployed and educated male labor force (% of population) of Belarus in 2001 to that in 2004?
Your response must be concise. 0.62. What is the ratio of the Unemployed and educated male labor force (% of population) of Hong Kong in 2001 to that in 2004?
Keep it short and to the point. 1.02. What is the ratio of the Unemployed and educated male labor force (% of population) in Lower middle income in 2001 to that in 2005?
Offer a terse response. 0.9. What is the ratio of the Unemployed and educated male labor force (% of population) in North America in 2001 to that in 2005?
Keep it short and to the point. 1.07. What is the ratio of the Unemployed and educated male labor force (% of population) in Belarus in 2001 to that in 2005?
Give a very brief answer. 0.65. What is the ratio of the Unemployed and educated male labor force (% of population) in Hong Kong in 2001 to that in 2005?
Keep it short and to the point. 1.05. What is the ratio of the Unemployed and educated male labor force (% of population) in Lower middle income in 2002 to that in 2003?
Your answer should be very brief. 1.02. What is the ratio of the Unemployed and educated male labor force (% of population) in North America in 2002 to that in 2003?
Keep it short and to the point. 1.04. What is the ratio of the Unemployed and educated male labor force (% of population) of Belarus in 2002 to that in 2003?
Provide a succinct answer. 0.99. What is the ratio of the Unemployed and educated male labor force (% of population) in Hong Kong in 2002 to that in 2003?
Offer a very short reply. 0.96. What is the ratio of the Unemployed and educated male labor force (% of population) in Lower middle income in 2002 to that in 2004?
Ensure brevity in your answer.  0.98. What is the ratio of the Unemployed and educated male labor force (% of population) in Belarus in 2002 to that in 2004?
Offer a terse response. 0.8. What is the ratio of the Unemployed and educated male labor force (% of population) in Hong Kong in 2002 to that in 2004?
Keep it short and to the point. 0.98. What is the ratio of the Unemployed and educated male labor force (% of population) of Lower middle income in 2002 to that in 2005?
Offer a terse response. 0.91. What is the ratio of the Unemployed and educated male labor force (% of population) in North America in 2002 to that in 2005?
Provide a short and direct response. 1.03. What is the ratio of the Unemployed and educated male labor force (% of population) in Belarus in 2002 to that in 2005?
Make the answer very short. 0.85. What is the ratio of the Unemployed and educated male labor force (% of population) in Hong Kong in 2002 to that in 2005?
Provide a succinct answer. 1.02. What is the ratio of the Unemployed and educated male labor force (% of population) of Lower middle income in 2003 to that in 2004?
Keep it short and to the point. 0.96. What is the ratio of the Unemployed and educated male labor force (% of population) of Belarus in 2003 to that in 2004?
Make the answer very short. 0.81. What is the ratio of the Unemployed and educated male labor force (% of population) of Hong Kong in 2003 to that in 2004?
Keep it short and to the point. 1.03. What is the ratio of the Unemployed and educated male labor force (% of population) in Lower middle income in 2003 to that in 2005?
Offer a very short reply. 0.89. What is the ratio of the Unemployed and educated male labor force (% of population) of Belarus in 2003 to that in 2005?
Give a very brief answer. 0.86. What is the ratio of the Unemployed and educated male labor force (% of population) of Hong Kong in 2003 to that in 2005?
Provide a short and direct response. 1.06. What is the ratio of the Unemployed and educated male labor force (% of population) of Lower middle income in 2004 to that in 2005?
Your response must be concise. 0.93. What is the ratio of the Unemployed and educated male labor force (% of population) in North America in 2004 to that in 2005?
Keep it short and to the point. 1.03. What is the ratio of the Unemployed and educated male labor force (% of population) in Belarus in 2004 to that in 2005?
Give a very brief answer. 1.06. What is the ratio of the Unemployed and educated male labor force (% of population) of Hong Kong in 2004 to that in 2005?
Ensure brevity in your answer.  1.03. What is the difference between the highest and the second highest Unemployed and educated male labor force (% of population) of Lower middle income?
Offer a very short reply. 1.94. What is the difference between the highest and the second highest Unemployed and educated male labor force (% of population) in North America?
Make the answer very short. 1.88. What is the difference between the highest and the second highest Unemployed and educated male labor force (% of population) in Belarus?
Your answer should be compact. 0.6. What is the difference between the highest and the second highest Unemployed and educated male labor force (% of population) in Hong Kong?
Provide a succinct answer. 0.9. What is the difference between the highest and the lowest Unemployed and educated male labor force (% of population) in Lower middle income?
Make the answer very short. 3.78. What is the difference between the highest and the lowest Unemployed and educated male labor force (% of population) of North America?
Your response must be concise. 3.48. 